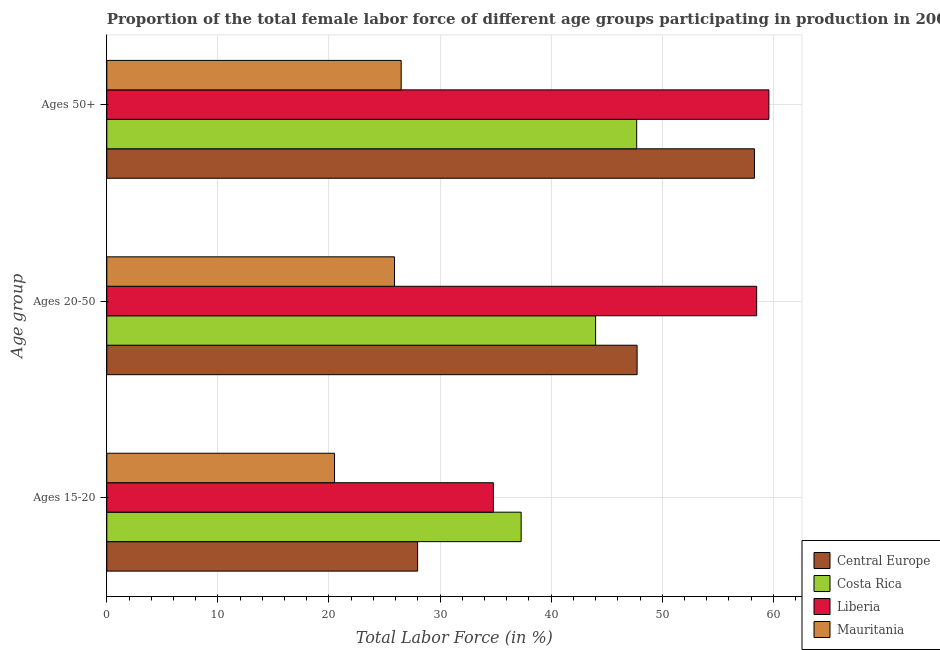How many groups of bars are there?
Offer a terse response. 3. How many bars are there on the 3rd tick from the top?
Keep it short and to the point. 4. What is the label of the 3rd group of bars from the top?
Your response must be concise. Ages 15-20. What is the percentage of female labor force above age 50 in Central Europe?
Provide a succinct answer. 58.3. Across all countries, what is the maximum percentage of female labor force within the age group 20-50?
Ensure brevity in your answer.  58.5. In which country was the percentage of female labor force within the age group 20-50 maximum?
Your response must be concise. Liberia. In which country was the percentage of female labor force within the age group 15-20 minimum?
Keep it short and to the point. Mauritania. What is the total percentage of female labor force above age 50 in the graph?
Offer a terse response. 192.1. What is the difference between the percentage of female labor force within the age group 15-20 in Liberia and that in Costa Rica?
Your response must be concise. -2.5. What is the difference between the percentage of female labor force within the age group 15-20 in Central Europe and the percentage of female labor force above age 50 in Costa Rica?
Provide a succinct answer. -19.72. What is the average percentage of female labor force within the age group 20-50 per country?
Offer a very short reply. 44.03. What is the difference between the percentage of female labor force within the age group 15-20 and percentage of female labor force within the age group 20-50 in Costa Rica?
Your answer should be very brief. -6.7. What is the ratio of the percentage of female labor force within the age group 20-50 in Liberia to that in Mauritania?
Ensure brevity in your answer.  2.26. Is the percentage of female labor force within the age group 15-20 in Costa Rica less than that in Liberia?
Provide a succinct answer. No. Is the difference between the percentage of female labor force within the age group 20-50 in Costa Rica and Liberia greater than the difference between the percentage of female labor force above age 50 in Costa Rica and Liberia?
Provide a short and direct response. No. What is the difference between the highest and the second highest percentage of female labor force above age 50?
Provide a succinct answer. 1.3. What is the difference between the highest and the lowest percentage of female labor force above age 50?
Offer a very short reply. 33.1. What does the 4th bar from the top in Ages 50+ represents?
Offer a very short reply. Central Europe. What does the 2nd bar from the bottom in Ages 50+ represents?
Ensure brevity in your answer.  Costa Rica. Is it the case that in every country, the sum of the percentage of female labor force within the age group 15-20 and percentage of female labor force within the age group 20-50 is greater than the percentage of female labor force above age 50?
Offer a very short reply. Yes. How many bars are there?
Make the answer very short. 12. How many countries are there in the graph?
Provide a short and direct response. 4. What is the difference between two consecutive major ticks on the X-axis?
Provide a short and direct response. 10. Are the values on the major ticks of X-axis written in scientific E-notation?
Keep it short and to the point. No. Does the graph contain any zero values?
Your answer should be very brief. No. Does the graph contain grids?
Provide a short and direct response. Yes. How many legend labels are there?
Provide a succinct answer. 4. How are the legend labels stacked?
Your answer should be compact. Vertical. What is the title of the graph?
Provide a succinct answer. Proportion of the total female labor force of different age groups participating in production in 2005. Does "World" appear as one of the legend labels in the graph?
Keep it short and to the point. No. What is the label or title of the Y-axis?
Offer a very short reply. Age group. What is the Total Labor Force (in %) of Central Europe in Ages 15-20?
Ensure brevity in your answer.  27.98. What is the Total Labor Force (in %) of Costa Rica in Ages 15-20?
Your answer should be compact. 37.3. What is the Total Labor Force (in %) of Liberia in Ages 15-20?
Your answer should be very brief. 34.8. What is the Total Labor Force (in %) in Mauritania in Ages 15-20?
Offer a terse response. 20.5. What is the Total Labor Force (in %) of Central Europe in Ages 20-50?
Provide a succinct answer. 47.74. What is the Total Labor Force (in %) in Liberia in Ages 20-50?
Provide a succinct answer. 58.5. What is the Total Labor Force (in %) in Mauritania in Ages 20-50?
Provide a short and direct response. 25.9. What is the Total Labor Force (in %) in Central Europe in Ages 50+?
Provide a succinct answer. 58.3. What is the Total Labor Force (in %) in Costa Rica in Ages 50+?
Your answer should be compact. 47.7. What is the Total Labor Force (in %) in Liberia in Ages 50+?
Your answer should be compact. 59.6. What is the Total Labor Force (in %) in Mauritania in Ages 50+?
Your answer should be compact. 26.5. Across all Age group, what is the maximum Total Labor Force (in %) of Central Europe?
Offer a terse response. 58.3. Across all Age group, what is the maximum Total Labor Force (in %) in Costa Rica?
Your answer should be very brief. 47.7. Across all Age group, what is the maximum Total Labor Force (in %) of Liberia?
Keep it short and to the point. 59.6. Across all Age group, what is the minimum Total Labor Force (in %) of Central Europe?
Your answer should be compact. 27.98. Across all Age group, what is the minimum Total Labor Force (in %) of Costa Rica?
Your answer should be compact. 37.3. Across all Age group, what is the minimum Total Labor Force (in %) in Liberia?
Give a very brief answer. 34.8. What is the total Total Labor Force (in %) of Central Europe in the graph?
Keep it short and to the point. 134.02. What is the total Total Labor Force (in %) of Costa Rica in the graph?
Keep it short and to the point. 129. What is the total Total Labor Force (in %) of Liberia in the graph?
Your answer should be compact. 152.9. What is the total Total Labor Force (in %) in Mauritania in the graph?
Ensure brevity in your answer.  72.9. What is the difference between the Total Labor Force (in %) in Central Europe in Ages 15-20 and that in Ages 20-50?
Your answer should be very brief. -19.76. What is the difference between the Total Labor Force (in %) in Liberia in Ages 15-20 and that in Ages 20-50?
Your response must be concise. -23.7. What is the difference between the Total Labor Force (in %) in Central Europe in Ages 15-20 and that in Ages 50+?
Provide a succinct answer. -30.32. What is the difference between the Total Labor Force (in %) of Liberia in Ages 15-20 and that in Ages 50+?
Offer a very short reply. -24.8. What is the difference between the Total Labor Force (in %) of Central Europe in Ages 20-50 and that in Ages 50+?
Give a very brief answer. -10.56. What is the difference between the Total Labor Force (in %) in Costa Rica in Ages 20-50 and that in Ages 50+?
Your answer should be compact. -3.7. What is the difference between the Total Labor Force (in %) of Liberia in Ages 20-50 and that in Ages 50+?
Ensure brevity in your answer.  -1.1. What is the difference between the Total Labor Force (in %) of Central Europe in Ages 15-20 and the Total Labor Force (in %) of Costa Rica in Ages 20-50?
Your answer should be compact. -16.02. What is the difference between the Total Labor Force (in %) in Central Europe in Ages 15-20 and the Total Labor Force (in %) in Liberia in Ages 20-50?
Your response must be concise. -30.52. What is the difference between the Total Labor Force (in %) of Central Europe in Ages 15-20 and the Total Labor Force (in %) of Mauritania in Ages 20-50?
Give a very brief answer. 2.08. What is the difference between the Total Labor Force (in %) of Costa Rica in Ages 15-20 and the Total Labor Force (in %) of Liberia in Ages 20-50?
Your response must be concise. -21.2. What is the difference between the Total Labor Force (in %) of Liberia in Ages 15-20 and the Total Labor Force (in %) of Mauritania in Ages 20-50?
Ensure brevity in your answer.  8.9. What is the difference between the Total Labor Force (in %) in Central Europe in Ages 15-20 and the Total Labor Force (in %) in Costa Rica in Ages 50+?
Your answer should be compact. -19.72. What is the difference between the Total Labor Force (in %) in Central Europe in Ages 15-20 and the Total Labor Force (in %) in Liberia in Ages 50+?
Your response must be concise. -31.62. What is the difference between the Total Labor Force (in %) in Central Europe in Ages 15-20 and the Total Labor Force (in %) in Mauritania in Ages 50+?
Ensure brevity in your answer.  1.48. What is the difference between the Total Labor Force (in %) of Costa Rica in Ages 15-20 and the Total Labor Force (in %) of Liberia in Ages 50+?
Your answer should be compact. -22.3. What is the difference between the Total Labor Force (in %) in Costa Rica in Ages 15-20 and the Total Labor Force (in %) in Mauritania in Ages 50+?
Your answer should be compact. 10.8. What is the difference between the Total Labor Force (in %) of Central Europe in Ages 20-50 and the Total Labor Force (in %) of Costa Rica in Ages 50+?
Provide a succinct answer. 0.04. What is the difference between the Total Labor Force (in %) of Central Europe in Ages 20-50 and the Total Labor Force (in %) of Liberia in Ages 50+?
Keep it short and to the point. -11.86. What is the difference between the Total Labor Force (in %) of Central Europe in Ages 20-50 and the Total Labor Force (in %) of Mauritania in Ages 50+?
Offer a terse response. 21.24. What is the difference between the Total Labor Force (in %) of Costa Rica in Ages 20-50 and the Total Labor Force (in %) of Liberia in Ages 50+?
Provide a short and direct response. -15.6. What is the average Total Labor Force (in %) in Central Europe per Age group?
Offer a very short reply. 44.67. What is the average Total Labor Force (in %) in Liberia per Age group?
Ensure brevity in your answer.  50.97. What is the average Total Labor Force (in %) of Mauritania per Age group?
Make the answer very short. 24.3. What is the difference between the Total Labor Force (in %) of Central Europe and Total Labor Force (in %) of Costa Rica in Ages 15-20?
Offer a very short reply. -9.32. What is the difference between the Total Labor Force (in %) of Central Europe and Total Labor Force (in %) of Liberia in Ages 15-20?
Your response must be concise. -6.82. What is the difference between the Total Labor Force (in %) of Central Europe and Total Labor Force (in %) of Mauritania in Ages 15-20?
Your answer should be compact. 7.48. What is the difference between the Total Labor Force (in %) in Costa Rica and Total Labor Force (in %) in Liberia in Ages 15-20?
Offer a very short reply. 2.5. What is the difference between the Total Labor Force (in %) of Costa Rica and Total Labor Force (in %) of Mauritania in Ages 15-20?
Offer a very short reply. 16.8. What is the difference between the Total Labor Force (in %) of Liberia and Total Labor Force (in %) of Mauritania in Ages 15-20?
Your answer should be very brief. 14.3. What is the difference between the Total Labor Force (in %) in Central Europe and Total Labor Force (in %) in Costa Rica in Ages 20-50?
Keep it short and to the point. 3.74. What is the difference between the Total Labor Force (in %) of Central Europe and Total Labor Force (in %) of Liberia in Ages 20-50?
Your response must be concise. -10.76. What is the difference between the Total Labor Force (in %) of Central Europe and Total Labor Force (in %) of Mauritania in Ages 20-50?
Offer a very short reply. 21.84. What is the difference between the Total Labor Force (in %) of Costa Rica and Total Labor Force (in %) of Liberia in Ages 20-50?
Keep it short and to the point. -14.5. What is the difference between the Total Labor Force (in %) in Liberia and Total Labor Force (in %) in Mauritania in Ages 20-50?
Make the answer very short. 32.6. What is the difference between the Total Labor Force (in %) of Central Europe and Total Labor Force (in %) of Costa Rica in Ages 50+?
Provide a short and direct response. 10.6. What is the difference between the Total Labor Force (in %) in Central Europe and Total Labor Force (in %) in Liberia in Ages 50+?
Offer a terse response. -1.3. What is the difference between the Total Labor Force (in %) of Central Europe and Total Labor Force (in %) of Mauritania in Ages 50+?
Ensure brevity in your answer.  31.8. What is the difference between the Total Labor Force (in %) of Costa Rica and Total Labor Force (in %) of Mauritania in Ages 50+?
Give a very brief answer. 21.2. What is the difference between the Total Labor Force (in %) of Liberia and Total Labor Force (in %) of Mauritania in Ages 50+?
Your response must be concise. 33.1. What is the ratio of the Total Labor Force (in %) of Central Europe in Ages 15-20 to that in Ages 20-50?
Provide a succinct answer. 0.59. What is the ratio of the Total Labor Force (in %) of Costa Rica in Ages 15-20 to that in Ages 20-50?
Ensure brevity in your answer.  0.85. What is the ratio of the Total Labor Force (in %) of Liberia in Ages 15-20 to that in Ages 20-50?
Your answer should be compact. 0.59. What is the ratio of the Total Labor Force (in %) of Mauritania in Ages 15-20 to that in Ages 20-50?
Your answer should be very brief. 0.79. What is the ratio of the Total Labor Force (in %) of Central Europe in Ages 15-20 to that in Ages 50+?
Your response must be concise. 0.48. What is the ratio of the Total Labor Force (in %) in Costa Rica in Ages 15-20 to that in Ages 50+?
Offer a terse response. 0.78. What is the ratio of the Total Labor Force (in %) of Liberia in Ages 15-20 to that in Ages 50+?
Your answer should be compact. 0.58. What is the ratio of the Total Labor Force (in %) in Mauritania in Ages 15-20 to that in Ages 50+?
Give a very brief answer. 0.77. What is the ratio of the Total Labor Force (in %) of Central Europe in Ages 20-50 to that in Ages 50+?
Ensure brevity in your answer.  0.82. What is the ratio of the Total Labor Force (in %) of Costa Rica in Ages 20-50 to that in Ages 50+?
Your answer should be very brief. 0.92. What is the ratio of the Total Labor Force (in %) in Liberia in Ages 20-50 to that in Ages 50+?
Your response must be concise. 0.98. What is the ratio of the Total Labor Force (in %) in Mauritania in Ages 20-50 to that in Ages 50+?
Make the answer very short. 0.98. What is the difference between the highest and the second highest Total Labor Force (in %) in Central Europe?
Give a very brief answer. 10.56. What is the difference between the highest and the second highest Total Labor Force (in %) in Liberia?
Provide a succinct answer. 1.1. What is the difference between the highest and the lowest Total Labor Force (in %) of Central Europe?
Offer a terse response. 30.32. What is the difference between the highest and the lowest Total Labor Force (in %) of Liberia?
Your answer should be very brief. 24.8. 